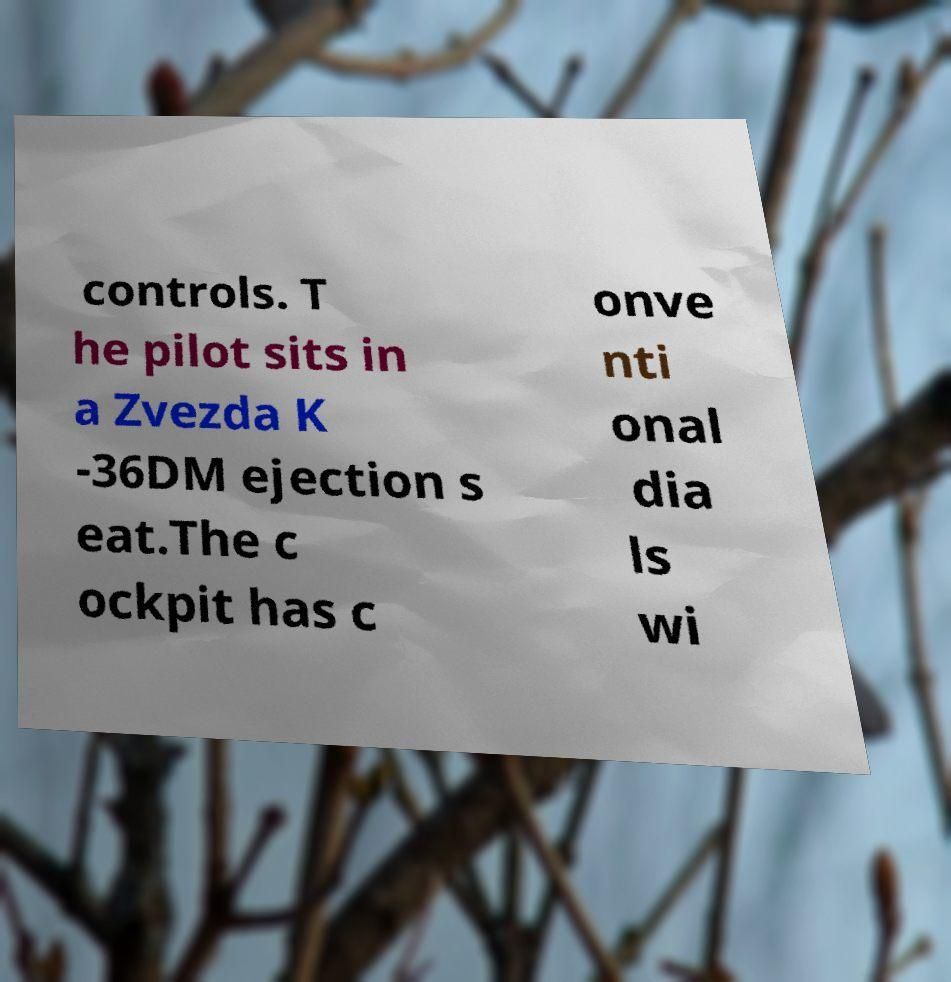There's text embedded in this image that I need extracted. Can you transcribe it verbatim? controls. T he pilot sits in a Zvezda K -36DM ejection s eat.The c ockpit has c onve nti onal dia ls wi 